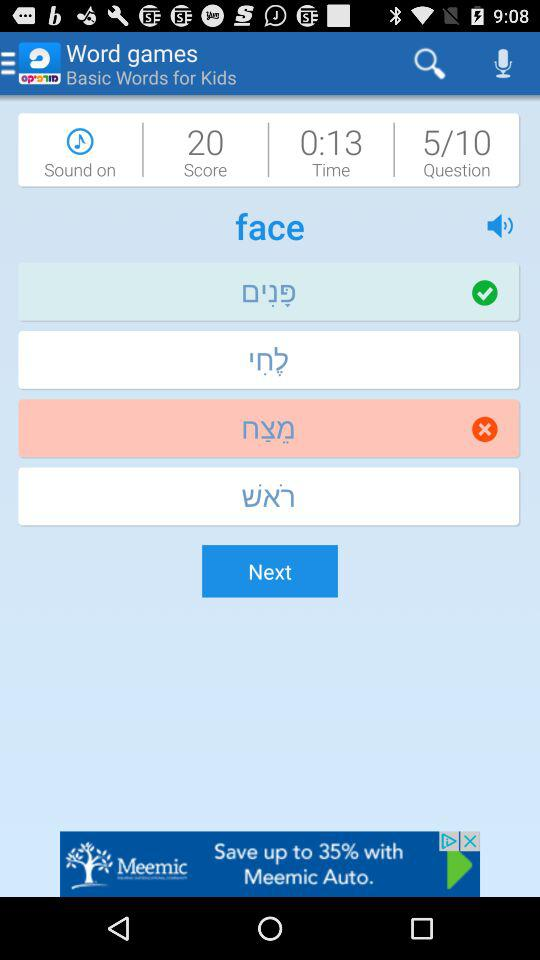How much time is left? The time left is 13 seconds. 